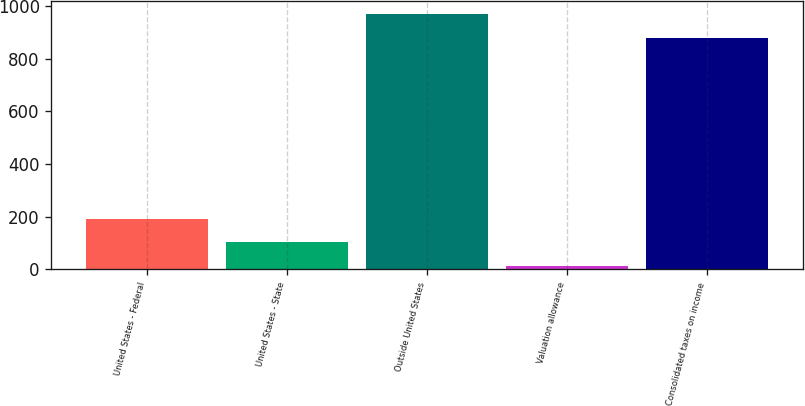Convert chart to OTSL. <chart><loc_0><loc_0><loc_500><loc_500><bar_chart><fcel>United States - Federal<fcel>United States - State<fcel>Outside United States<fcel>Valuation allowance<fcel>Consolidated taxes on income<nl><fcel>191.6<fcel>102.3<fcel>968.3<fcel>13<fcel>879<nl></chart> 